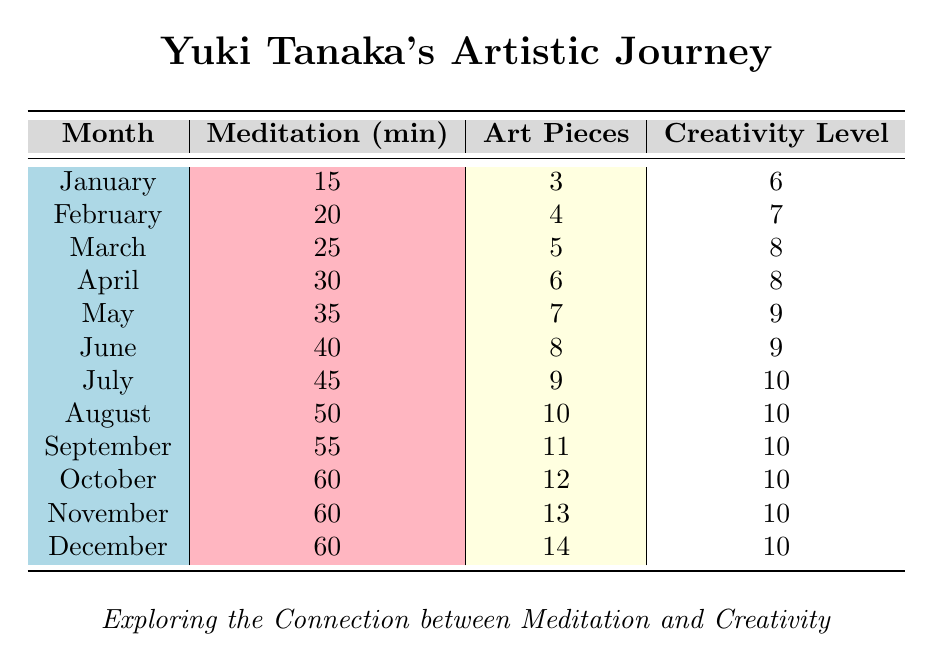What was the highest perceived creativity level recorded in the data? The perceived creativity levels for each month are listed in the last column. Scanning through the data, the highest value found is 10, which occurs in multiple months.
Answer: 10 In which month did Yuki Tanaka complete the most art pieces? Looking at the "Art Pieces" column, the highest number of completed pieces is 14, found in December.
Answer: December What is the total number of art pieces completed by Yuki Tanaka throughout the year? We can sum the "Art Pieces" column: 3 + 4 + 5 + 6 + 7 + 8 + 9 + 10 + 11 + 12 + 13 + 14 = 3 + 4 = 7, 7 + 5 = 12, 12 + 6 = 18, 18 + 7 = 25, 25 + 8 = 33, 33 + 9 = 42, 42 + 10 = 52, 52 + 11 = 63, 63 + 12 = 75, 75 + 13 = 88, and 88 + 14 = 102. The total is 102.
Answer: 102 Did meditation duration reach its maximum value in December? Checking the "Meditation (min)" column, we see that the meditation duration remains at 60 minutes for December but does not exceed 60 in previous months.
Answer: Yes What is the average meditation duration across all months? To compute the average, first we sum the meditation durations: 15 + 20 + 25 + 30 + 35 + 40 + 45 + 50 + 55 + 60 + 60 + 60 = 15 + 20 = 35, 35 + 25 = 60, 60 + 30 = 90, 90 + 35 = 125, 125 + 40 = 165, 165 + 45 = 210, 210 + 50 = 260, 260 + 55 = 315, 315 + 60 = 375, 375 + 60 = 435, 435 + 60 = 495. The average is 495 divided by 12 (the number of months), which gives approximately 41.25.
Answer: 41.25 How many months had a perceived creativity level of 10? By checking the "Creativity Level" column, we find that 10 appears in July, August, September, October, November, and December. Counting these gives us 6 months.
Answer: 6 